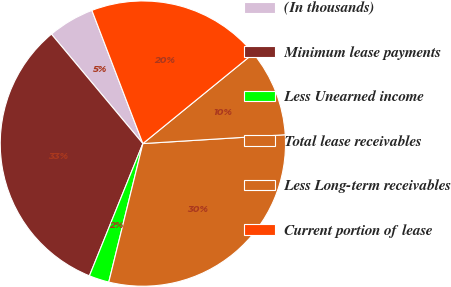Convert chart to OTSL. <chart><loc_0><loc_0><loc_500><loc_500><pie_chart><fcel>(In thousands)<fcel>Minimum lease payments<fcel>Less Unearned income<fcel>Total lease receivables<fcel>Less Long-term receivables<fcel>Current portion of lease<nl><fcel>5.26%<fcel>32.81%<fcel>2.27%<fcel>29.83%<fcel>9.9%<fcel>19.93%<nl></chart> 